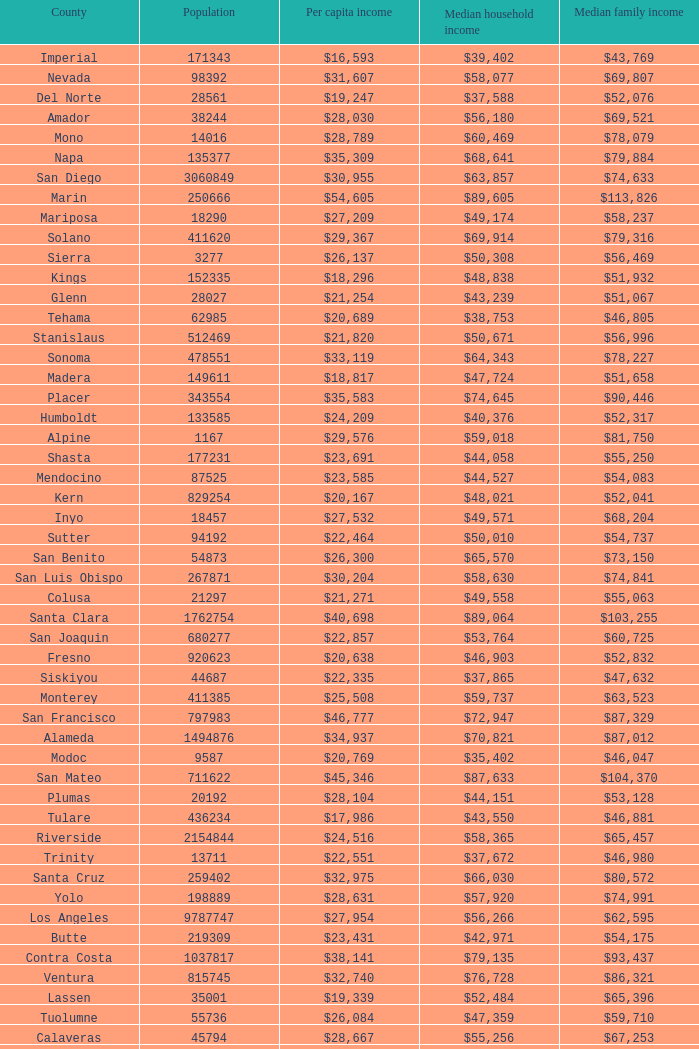What is the median household income of sacramento? $56,553. 